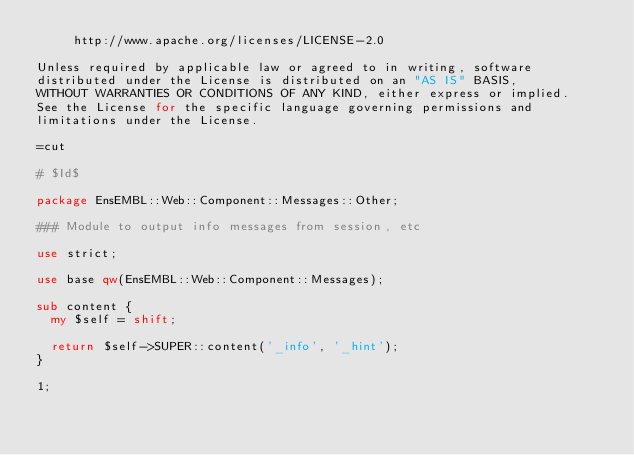Convert code to text. <code><loc_0><loc_0><loc_500><loc_500><_Perl_>     http://www.apache.org/licenses/LICENSE-2.0

Unless required by applicable law or agreed to in writing, software
distributed under the License is distributed on an "AS IS" BASIS,
WITHOUT WARRANTIES OR CONDITIONS OF ANY KIND, either express or implied.
See the License for the specific language governing permissions and
limitations under the License.

=cut

# $Id$

package EnsEMBL::Web::Component::Messages::Other;

### Module to output info messages from session, etc

use strict;

use base qw(EnsEMBL::Web::Component::Messages);

sub content {
  my $self = shift;
  
  return $self->SUPER::content('_info', '_hint'); 
}

1;
</code> 